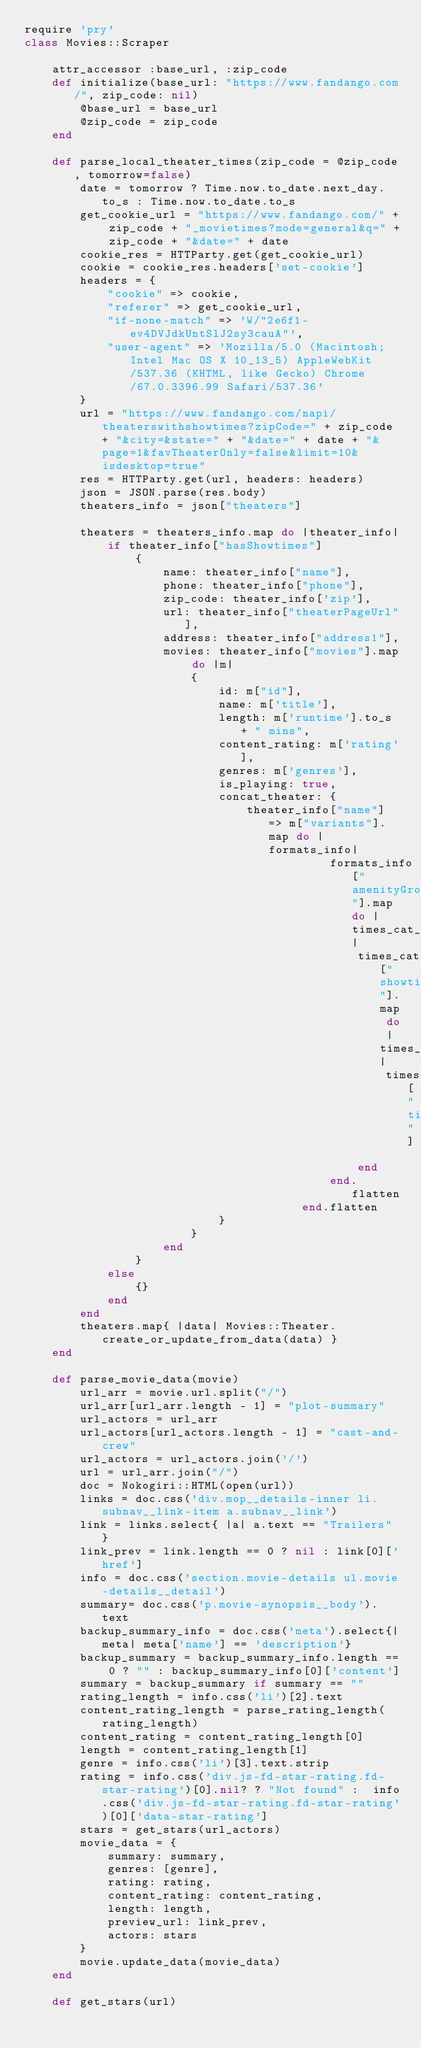Convert code to text. <code><loc_0><loc_0><loc_500><loc_500><_Ruby_>require 'pry'
class Movies::Scraper

    attr_accessor :base_url, :zip_code
    def initialize(base_url: "https://www.fandango.com/", zip_code: nil)
        @base_url = base_url
        @zip_code = zip_code
    end

    def parse_local_theater_times(zip_code = @zip_code, tomorrow=false)
        date = tomorrow ? Time.now.to_date.next_day.to_s : Time.now.to_date.to_s
        get_cookie_url = "https://www.fandango.com/" + zip_code + "_movietimes?mode=general&q=" + zip_code + "&date=" + date
        cookie_res = HTTParty.get(get_cookie_url)
        cookie = cookie_res.headers['set-cookie']
        headers = {
            "cookie" => cookie,
            "referer" => get_cookie_url,
            "if-none-match" => 'W/"2e6f1-ev4DVJdkUntSlJ2sy3cauA"',
            "user-agent" => 'Mozilla/5.0 (Macintosh; Intel Mac OS X 10_13_5) AppleWebKit/537.36 (KHTML, like Gecko) Chrome/67.0.3396.99 Safari/537.36'
        }
        url = "https://www.fandango.com/napi/theaterswithshowtimes?zipCode=" + zip_code + "&city=&state=" + "&date=" + date + "&page=1&favTheaterOnly=false&limit=10&isdesktop=true"
        res = HTTParty.get(url, headers: headers)
        json = JSON.parse(res.body)
        theaters_info = json["theaters"]
        
        theaters = theaters_info.map do |theater_info|
            if theater_info["hasShowtimes"]
                {
                    name: theater_info["name"],
                    phone: theater_info["phone"],
                    zip_code: theater_info['zip'],
                    url: theater_info["theaterPageUrl"],
                    address: theater_info["address1"],
                    movies: theater_info["movies"].map do |m| 
                        {
                            id: m["id"],
                            name: m['title'],
                            length: m['runtime'].to_s + " mins",
                            content_rating: m['rating'],
                            genres: m['genres'],
                            is_playing: true,
                            concat_theater: {
                                theater_info["name"] => m["variants"].map do |formats_info|
                                            formats_info["amenityGroups"].map do |times_cat_hash|
                                                times_cat_hash["showtimes"].map do |times_hash|
                                                    times_hash["ticketingDate"]
                                                end
                                            end.flatten
                                        end.flatten
                            }
                        }
                    end
                }
            else
                {}
            end
        end
        theaters.map{ |data| Movies::Theater.create_or_update_from_data(data) }
    end

    def parse_movie_data(movie)
        url_arr = movie.url.split("/")
        url_arr[url_arr.length - 1] = "plot-summary"
        url_actors = url_arr
        url_actors[url_actors.length - 1] = "cast-and-crew"
        url_actors = url_actors.join('/')
        url = url_arr.join("/")
        doc = Nokogiri::HTML(open(url))
        links = doc.css('div.mop__details-inner li.subnav__link-item a.subnav__link')
        link = links.select{ |a| a.text == "Trailers" }
        link_prev = link.length == 0 ? nil : link[0]['href']
        info = doc.css('section.movie-details ul.movie-details__detail')
        summary= doc.css('p.movie-synopsis__body').text
        backup_summary_info = doc.css('meta').select{|meta| meta['name'] == 'description'}
        backup_summary = backup_summary_info.length == 0 ? "" : backup_summary_info[0]['content']
        summary = backup_summary if summary == ""
        rating_length = info.css('li')[2].text
        content_rating_length = parse_rating_length(rating_length)
        content_rating = content_rating_length[0]
        length = content_rating_length[1]
        genre = info.css('li')[3].text.strip
        rating = info.css('div.js-fd-star-rating.fd-star-rating')[0].nil? ? "Not found" :  info.css('div.js-fd-star-rating.fd-star-rating')[0]['data-star-rating']
        stars = get_stars(url_actors)
        movie_data = {
            summary: summary,
            genres: [genre],
            rating: rating,
            content_rating: content_rating,
            length: length,
            preview_url: link_prev,
            actors: stars
        }
        movie.update_data(movie_data)
    end

    def get_stars(url)</code> 